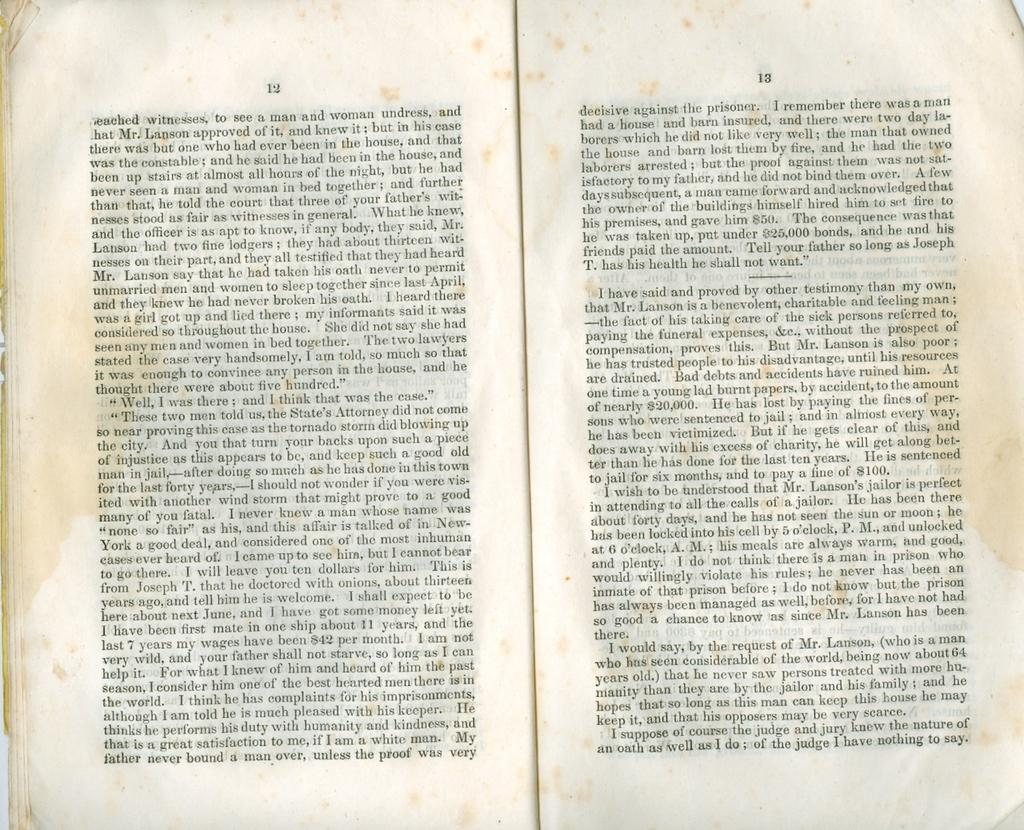<image>
Write a terse but informative summary of the picture. Vintage pages of text that is opened to page 12 and 13. 